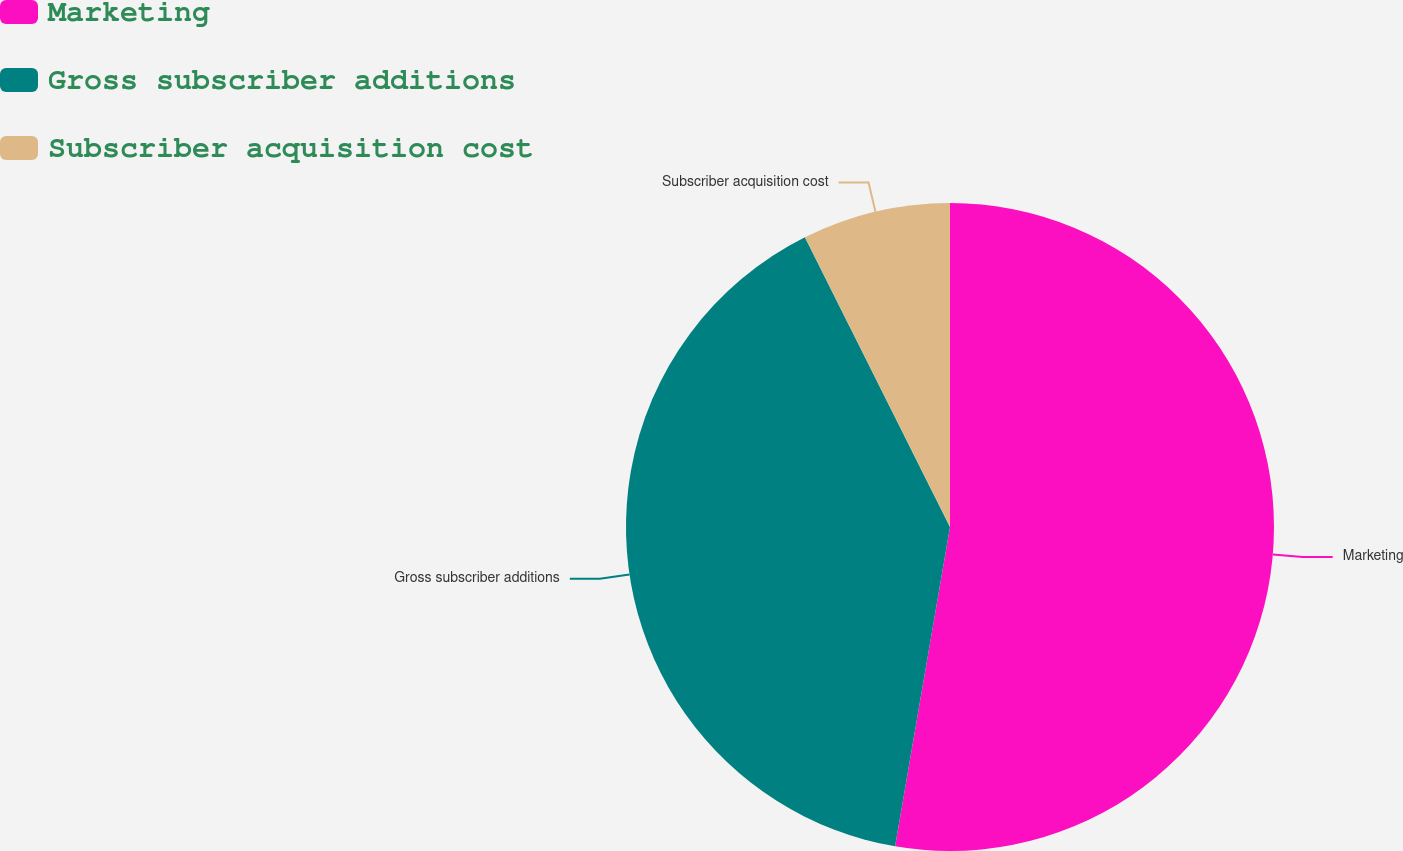<chart> <loc_0><loc_0><loc_500><loc_500><pie_chart><fcel>Marketing<fcel>Gross subscriber additions<fcel>Subscriber acquisition cost<nl><fcel>52.71%<fcel>39.9%<fcel>7.39%<nl></chart> 